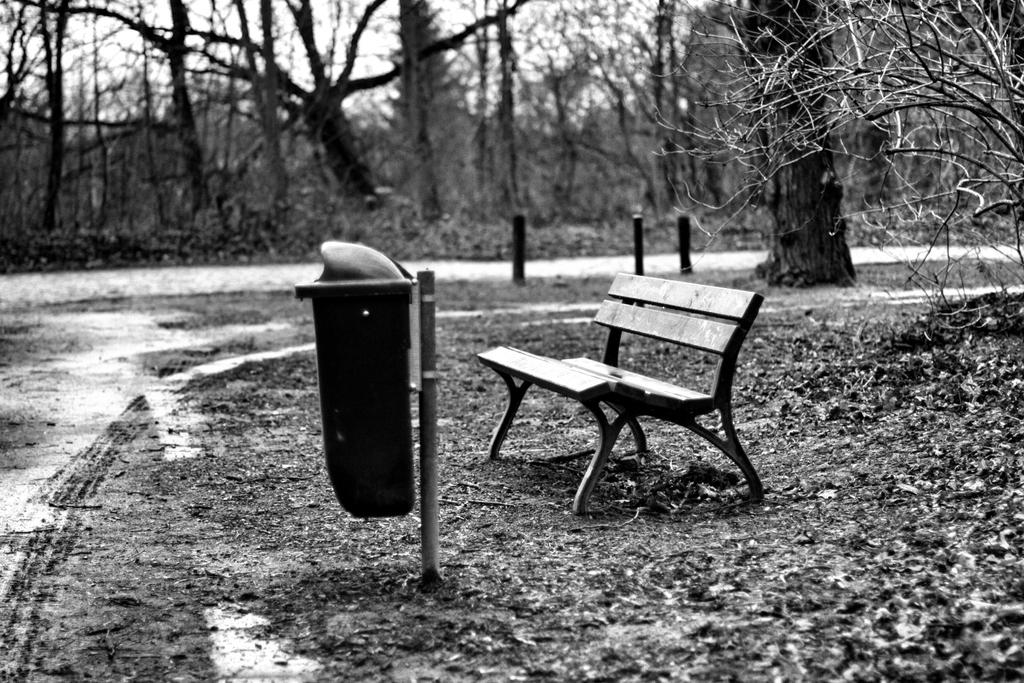What type of outdoor furniture is present in the image? There is a park bench in the image. What is another object related to cleanliness and waste management in the image? There is a dustbin in the image. How many chairs are visible in the image? There are many chairs in the image. What type of flooring can be seen in the image? There is no information about the flooring in the image, as it only shows outdoor furniture and a dustbin. 